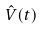Convert formula to latex. <formula><loc_0><loc_0><loc_500><loc_500>\hat { V } ( t )</formula> 